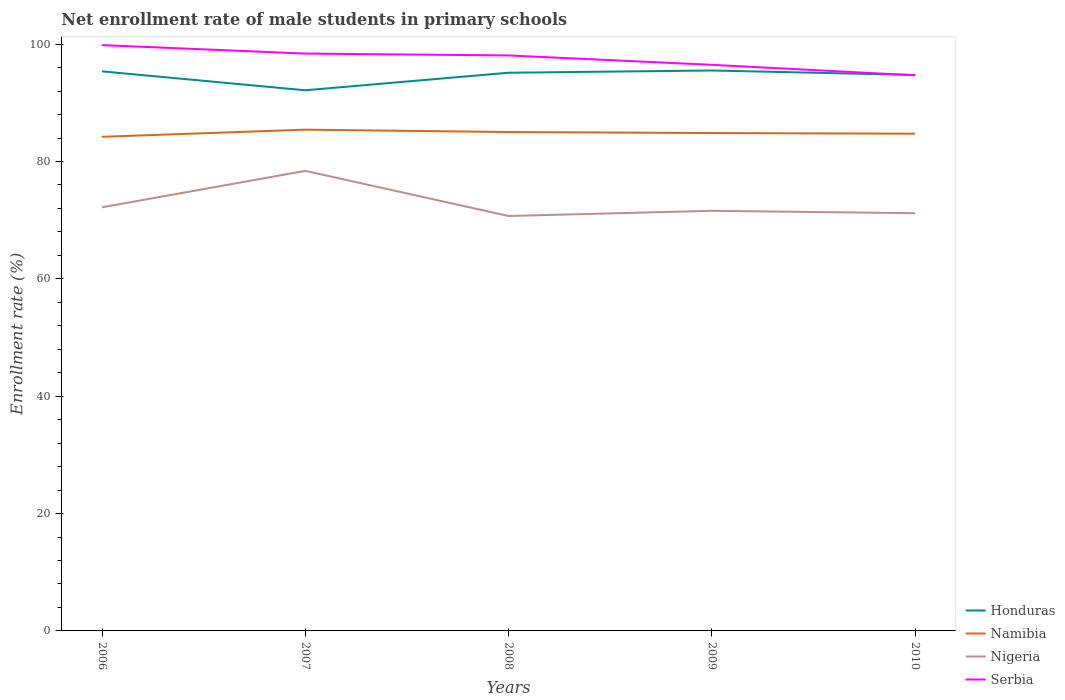Does the line corresponding to Nigeria intersect with the line corresponding to Serbia?
Keep it short and to the point. No. Across all years, what is the maximum net enrollment rate of male students in primary schools in Honduras?
Give a very brief answer. 92.14. What is the total net enrollment rate of male students in primary schools in Honduras in the graph?
Your answer should be compact. -2.99. What is the difference between the highest and the second highest net enrollment rate of male students in primary schools in Serbia?
Give a very brief answer. 5.15. What is the difference between the highest and the lowest net enrollment rate of male students in primary schools in Nigeria?
Keep it short and to the point. 1. How many years are there in the graph?
Your response must be concise. 5. Does the graph contain grids?
Offer a terse response. No. How many legend labels are there?
Your answer should be compact. 4. What is the title of the graph?
Ensure brevity in your answer.  Net enrollment rate of male students in primary schools. What is the label or title of the X-axis?
Provide a succinct answer. Years. What is the label or title of the Y-axis?
Your answer should be very brief. Enrollment rate (%). What is the Enrollment rate (%) of Honduras in 2006?
Keep it short and to the point. 95.37. What is the Enrollment rate (%) in Namibia in 2006?
Provide a short and direct response. 84.21. What is the Enrollment rate (%) of Nigeria in 2006?
Provide a succinct answer. 72.2. What is the Enrollment rate (%) of Serbia in 2006?
Your answer should be compact. 99.84. What is the Enrollment rate (%) of Honduras in 2007?
Your answer should be compact. 92.14. What is the Enrollment rate (%) of Namibia in 2007?
Offer a terse response. 85.43. What is the Enrollment rate (%) of Nigeria in 2007?
Your response must be concise. 78.4. What is the Enrollment rate (%) in Serbia in 2007?
Your answer should be compact. 98.4. What is the Enrollment rate (%) in Honduras in 2008?
Offer a very short reply. 95.13. What is the Enrollment rate (%) in Namibia in 2008?
Provide a succinct answer. 85.02. What is the Enrollment rate (%) in Nigeria in 2008?
Your response must be concise. 70.72. What is the Enrollment rate (%) of Serbia in 2008?
Keep it short and to the point. 98.08. What is the Enrollment rate (%) in Honduras in 2009?
Offer a terse response. 95.51. What is the Enrollment rate (%) in Namibia in 2009?
Give a very brief answer. 84.85. What is the Enrollment rate (%) in Nigeria in 2009?
Ensure brevity in your answer.  71.6. What is the Enrollment rate (%) of Serbia in 2009?
Your answer should be compact. 96.48. What is the Enrollment rate (%) of Honduras in 2010?
Keep it short and to the point. 94.75. What is the Enrollment rate (%) in Namibia in 2010?
Your answer should be very brief. 84.74. What is the Enrollment rate (%) in Nigeria in 2010?
Ensure brevity in your answer.  71.19. What is the Enrollment rate (%) of Serbia in 2010?
Provide a short and direct response. 94.69. Across all years, what is the maximum Enrollment rate (%) of Honduras?
Make the answer very short. 95.51. Across all years, what is the maximum Enrollment rate (%) in Namibia?
Your response must be concise. 85.43. Across all years, what is the maximum Enrollment rate (%) of Nigeria?
Provide a short and direct response. 78.4. Across all years, what is the maximum Enrollment rate (%) of Serbia?
Provide a succinct answer. 99.84. Across all years, what is the minimum Enrollment rate (%) in Honduras?
Offer a terse response. 92.14. Across all years, what is the minimum Enrollment rate (%) in Namibia?
Make the answer very short. 84.21. Across all years, what is the minimum Enrollment rate (%) of Nigeria?
Keep it short and to the point. 70.72. Across all years, what is the minimum Enrollment rate (%) of Serbia?
Provide a short and direct response. 94.69. What is the total Enrollment rate (%) in Honduras in the graph?
Give a very brief answer. 472.9. What is the total Enrollment rate (%) in Namibia in the graph?
Provide a short and direct response. 424.26. What is the total Enrollment rate (%) in Nigeria in the graph?
Keep it short and to the point. 364.11. What is the total Enrollment rate (%) of Serbia in the graph?
Ensure brevity in your answer.  487.48. What is the difference between the Enrollment rate (%) of Honduras in 2006 and that in 2007?
Offer a very short reply. 3.22. What is the difference between the Enrollment rate (%) in Namibia in 2006 and that in 2007?
Ensure brevity in your answer.  -1.22. What is the difference between the Enrollment rate (%) in Nigeria in 2006 and that in 2007?
Keep it short and to the point. -6.21. What is the difference between the Enrollment rate (%) in Serbia in 2006 and that in 2007?
Ensure brevity in your answer.  1.44. What is the difference between the Enrollment rate (%) in Honduras in 2006 and that in 2008?
Offer a very short reply. 0.24. What is the difference between the Enrollment rate (%) of Namibia in 2006 and that in 2008?
Make the answer very short. -0.81. What is the difference between the Enrollment rate (%) of Nigeria in 2006 and that in 2008?
Ensure brevity in your answer.  1.48. What is the difference between the Enrollment rate (%) in Serbia in 2006 and that in 2008?
Ensure brevity in your answer.  1.76. What is the difference between the Enrollment rate (%) in Honduras in 2006 and that in 2009?
Your answer should be very brief. -0.15. What is the difference between the Enrollment rate (%) in Namibia in 2006 and that in 2009?
Your response must be concise. -0.64. What is the difference between the Enrollment rate (%) in Nigeria in 2006 and that in 2009?
Provide a succinct answer. 0.6. What is the difference between the Enrollment rate (%) in Serbia in 2006 and that in 2009?
Give a very brief answer. 3.36. What is the difference between the Enrollment rate (%) of Honduras in 2006 and that in 2010?
Give a very brief answer. 0.61. What is the difference between the Enrollment rate (%) of Namibia in 2006 and that in 2010?
Make the answer very short. -0.53. What is the difference between the Enrollment rate (%) of Nigeria in 2006 and that in 2010?
Keep it short and to the point. 1. What is the difference between the Enrollment rate (%) of Serbia in 2006 and that in 2010?
Your answer should be very brief. 5.15. What is the difference between the Enrollment rate (%) of Honduras in 2007 and that in 2008?
Your response must be concise. -2.99. What is the difference between the Enrollment rate (%) of Namibia in 2007 and that in 2008?
Ensure brevity in your answer.  0.41. What is the difference between the Enrollment rate (%) in Nigeria in 2007 and that in 2008?
Provide a short and direct response. 7.69. What is the difference between the Enrollment rate (%) of Serbia in 2007 and that in 2008?
Make the answer very short. 0.32. What is the difference between the Enrollment rate (%) of Honduras in 2007 and that in 2009?
Your answer should be compact. -3.37. What is the difference between the Enrollment rate (%) of Namibia in 2007 and that in 2009?
Your response must be concise. 0.58. What is the difference between the Enrollment rate (%) in Nigeria in 2007 and that in 2009?
Give a very brief answer. 6.81. What is the difference between the Enrollment rate (%) in Serbia in 2007 and that in 2009?
Your answer should be compact. 1.92. What is the difference between the Enrollment rate (%) in Honduras in 2007 and that in 2010?
Keep it short and to the point. -2.61. What is the difference between the Enrollment rate (%) of Namibia in 2007 and that in 2010?
Ensure brevity in your answer.  0.69. What is the difference between the Enrollment rate (%) of Nigeria in 2007 and that in 2010?
Make the answer very short. 7.21. What is the difference between the Enrollment rate (%) in Serbia in 2007 and that in 2010?
Provide a succinct answer. 3.71. What is the difference between the Enrollment rate (%) in Honduras in 2008 and that in 2009?
Your answer should be very brief. -0.38. What is the difference between the Enrollment rate (%) of Namibia in 2008 and that in 2009?
Keep it short and to the point. 0.17. What is the difference between the Enrollment rate (%) of Nigeria in 2008 and that in 2009?
Provide a short and direct response. -0.88. What is the difference between the Enrollment rate (%) in Serbia in 2008 and that in 2009?
Your answer should be compact. 1.6. What is the difference between the Enrollment rate (%) of Honduras in 2008 and that in 2010?
Your response must be concise. 0.38. What is the difference between the Enrollment rate (%) in Namibia in 2008 and that in 2010?
Provide a short and direct response. 0.28. What is the difference between the Enrollment rate (%) in Nigeria in 2008 and that in 2010?
Your answer should be very brief. -0.48. What is the difference between the Enrollment rate (%) in Serbia in 2008 and that in 2010?
Provide a succinct answer. 3.39. What is the difference between the Enrollment rate (%) in Honduras in 2009 and that in 2010?
Make the answer very short. 0.76. What is the difference between the Enrollment rate (%) in Namibia in 2009 and that in 2010?
Offer a terse response. 0.11. What is the difference between the Enrollment rate (%) in Nigeria in 2009 and that in 2010?
Give a very brief answer. 0.4. What is the difference between the Enrollment rate (%) in Serbia in 2009 and that in 2010?
Your answer should be very brief. 1.79. What is the difference between the Enrollment rate (%) in Honduras in 2006 and the Enrollment rate (%) in Namibia in 2007?
Make the answer very short. 9.93. What is the difference between the Enrollment rate (%) of Honduras in 2006 and the Enrollment rate (%) of Nigeria in 2007?
Offer a very short reply. 16.96. What is the difference between the Enrollment rate (%) in Honduras in 2006 and the Enrollment rate (%) in Serbia in 2007?
Ensure brevity in your answer.  -3.03. What is the difference between the Enrollment rate (%) of Namibia in 2006 and the Enrollment rate (%) of Nigeria in 2007?
Offer a terse response. 5.81. What is the difference between the Enrollment rate (%) of Namibia in 2006 and the Enrollment rate (%) of Serbia in 2007?
Provide a short and direct response. -14.19. What is the difference between the Enrollment rate (%) in Nigeria in 2006 and the Enrollment rate (%) in Serbia in 2007?
Keep it short and to the point. -26.2. What is the difference between the Enrollment rate (%) of Honduras in 2006 and the Enrollment rate (%) of Namibia in 2008?
Your response must be concise. 10.34. What is the difference between the Enrollment rate (%) in Honduras in 2006 and the Enrollment rate (%) in Nigeria in 2008?
Your answer should be very brief. 24.65. What is the difference between the Enrollment rate (%) in Honduras in 2006 and the Enrollment rate (%) in Serbia in 2008?
Provide a succinct answer. -2.71. What is the difference between the Enrollment rate (%) of Namibia in 2006 and the Enrollment rate (%) of Nigeria in 2008?
Provide a short and direct response. 13.5. What is the difference between the Enrollment rate (%) of Namibia in 2006 and the Enrollment rate (%) of Serbia in 2008?
Your response must be concise. -13.86. What is the difference between the Enrollment rate (%) of Nigeria in 2006 and the Enrollment rate (%) of Serbia in 2008?
Make the answer very short. -25.88. What is the difference between the Enrollment rate (%) of Honduras in 2006 and the Enrollment rate (%) of Namibia in 2009?
Give a very brief answer. 10.51. What is the difference between the Enrollment rate (%) in Honduras in 2006 and the Enrollment rate (%) in Nigeria in 2009?
Keep it short and to the point. 23.77. What is the difference between the Enrollment rate (%) of Honduras in 2006 and the Enrollment rate (%) of Serbia in 2009?
Offer a terse response. -1.12. What is the difference between the Enrollment rate (%) of Namibia in 2006 and the Enrollment rate (%) of Nigeria in 2009?
Ensure brevity in your answer.  12.62. What is the difference between the Enrollment rate (%) of Namibia in 2006 and the Enrollment rate (%) of Serbia in 2009?
Provide a short and direct response. -12.27. What is the difference between the Enrollment rate (%) of Nigeria in 2006 and the Enrollment rate (%) of Serbia in 2009?
Your response must be concise. -24.29. What is the difference between the Enrollment rate (%) in Honduras in 2006 and the Enrollment rate (%) in Namibia in 2010?
Keep it short and to the point. 10.62. What is the difference between the Enrollment rate (%) of Honduras in 2006 and the Enrollment rate (%) of Nigeria in 2010?
Provide a succinct answer. 24.17. What is the difference between the Enrollment rate (%) of Honduras in 2006 and the Enrollment rate (%) of Serbia in 2010?
Offer a terse response. 0.68. What is the difference between the Enrollment rate (%) in Namibia in 2006 and the Enrollment rate (%) in Nigeria in 2010?
Make the answer very short. 13.02. What is the difference between the Enrollment rate (%) of Namibia in 2006 and the Enrollment rate (%) of Serbia in 2010?
Offer a very short reply. -10.48. What is the difference between the Enrollment rate (%) in Nigeria in 2006 and the Enrollment rate (%) in Serbia in 2010?
Give a very brief answer. -22.49. What is the difference between the Enrollment rate (%) in Honduras in 2007 and the Enrollment rate (%) in Namibia in 2008?
Keep it short and to the point. 7.12. What is the difference between the Enrollment rate (%) in Honduras in 2007 and the Enrollment rate (%) in Nigeria in 2008?
Give a very brief answer. 21.43. What is the difference between the Enrollment rate (%) in Honduras in 2007 and the Enrollment rate (%) in Serbia in 2008?
Make the answer very short. -5.94. What is the difference between the Enrollment rate (%) in Namibia in 2007 and the Enrollment rate (%) in Nigeria in 2008?
Your response must be concise. 14.71. What is the difference between the Enrollment rate (%) in Namibia in 2007 and the Enrollment rate (%) in Serbia in 2008?
Your response must be concise. -12.65. What is the difference between the Enrollment rate (%) in Nigeria in 2007 and the Enrollment rate (%) in Serbia in 2008?
Make the answer very short. -19.67. What is the difference between the Enrollment rate (%) in Honduras in 2007 and the Enrollment rate (%) in Namibia in 2009?
Give a very brief answer. 7.29. What is the difference between the Enrollment rate (%) of Honduras in 2007 and the Enrollment rate (%) of Nigeria in 2009?
Provide a short and direct response. 20.54. What is the difference between the Enrollment rate (%) in Honduras in 2007 and the Enrollment rate (%) in Serbia in 2009?
Keep it short and to the point. -4.34. What is the difference between the Enrollment rate (%) in Namibia in 2007 and the Enrollment rate (%) in Nigeria in 2009?
Ensure brevity in your answer.  13.83. What is the difference between the Enrollment rate (%) of Namibia in 2007 and the Enrollment rate (%) of Serbia in 2009?
Provide a succinct answer. -11.05. What is the difference between the Enrollment rate (%) of Nigeria in 2007 and the Enrollment rate (%) of Serbia in 2009?
Make the answer very short. -18.08. What is the difference between the Enrollment rate (%) of Honduras in 2007 and the Enrollment rate (%) of Namibia in 2010?
Offer a very short reply. 7.4. What is the difference between the Enrollment rate (%) of Honduras in 2007 and the Enrollment rate (%) of Nigeria in 2010?
Your response must be concise. 20.95. What is the difference between the Enrollment rate (%) in Honduras in 2007 and the Enrollment rate (%) in Serbia in 2010?
Offer a very short reply. -2.55. What is the difference between the Enrollment rate (%) in Namibia in 2007 and the Enrollment rate (%) in Nigeria in 2010?
Provide a short and direct response. 14.24. What is the difference between the Enrollment rate (%) in Namibia in 2007 and the Enrollment rate (%) in Serbia in 2010?
Ensure brevity in your answer.  -9.26. What is the difference between the Enrollment rate (%) of Nigeria in 2007 and the Enrollment rate (%) of Serbia in 2010?
Offer a terse response. -16.28. What is the difference between the Enrollment rate (%) of Honduras in 2008 and the Enrollment rate (%) of Namibia in 2009?
Give a very brief answer. 10.28. What is the difference between the Enrollment rate (%) of Honduras in 2008 and the Enrollment rate (%) of Nigeria in 2009?
Your response must be concise. 23.53. What is the difference between the Enrollment rate (%) in Honduras in 2008 and the Enrollment rate (%) in Serbia in 2009?
Offer a terse response. -1.35. What is the difference between the Enrollment rate (%) of Namibia in 2008 and the Enrollment rate (%) of Nigeria in 2009?
Your answer should be compact. 13.43. What is the difference between the Enrollment rate (%) in Namibia in 2008 and the Enrollment rate (%) in Serbia in 2009?
Make the answer very short. -11.46. What is the difference between the Enrollment rate (%) of Nigeria in 2008 and the Enrollment rate (%) of Serbia in 2009?
Offer a terse response. -25.77. What is the difference between the Enrollment rate (%) in Honduras in 2008 and the Enrollment rate (%) in Namibia in 2010?
Make the answer very short. 10.39. What is the difference between the Enrollment rate (%) in Honduras in 2008 and the Enrollment rate (%) in Nigeria in 2010?
Offer a terse response. 23.94. What is the difference between the Enrollment rate (%) of Honduras in 2008 and the Enrollment rate (%) of Serbia in 2010?
Offer a terse response. 0.44. What is the difference between the Enrollment rate (%) of Namibia in 2008 and the Enrollment rate (%) of Nigeria in 2010?
Offer a very short reply. 13.83. What is the difference between the Enrollment rate (%) of Namibia in 2008 and the Enrollment rate (%) of Serbia in 2010?
Give a very brief answer. -9.67. What is the difference between the Enrollment rate (%) in Nigeria in 2008 and the Enrollment rate (%) in Serbia in 2010?
Your response must be concise. -23.97. What is the difference between the Enrollment rate (%) of Honduras in 2009 and the Enrollment rate (%) of Namibia in 2010?
Keep it short and to the point. 10.77. What is the difference between the Enrollment rate (%) in Honduras in 2009 and the Enrollment rate (%) in Nigeria in 2010?
Offer a terse response. 24.32. What is the difference between the Enrollment rate (%) of Honduras in 2009 and the Enrollment rate (%) of Serbia in 2010?
Your response must be concise. 0.82. What is the difference between the Enrollment rate (%) in Namibia in 2009 and the Enrollment rate (%) in Nigeria in 2010?
Ensure brevity in your answer.  13.66. What is the difference between the Enrollment rate (%) of Namibia in 2009 and the Enrollment rate (%) of Serbia in 2010?
Ensure brevity in your answer.  -9.84. What is the difference between the Enrollment rate (%) of Nigeria in 2009 and the Enrollment rate (%) of Serbia in 2010?
Offer a very short reply. -23.09. What is the average Enrollment rate (%) in Honduras per year?
Your answer should be compact. 94.58. What is the average Enrollment rate (%) in Namibia per year?
Your response must be concise. 84.85. What is the average Enrollment rate (%) of Nigeria per year?
Provide a short and direct response. 72.82. What is the average Enrollment rate (%) in Serbia per year?
Provide a succinct answer. 97.5. In the year 2006, what is the difference between the Enrollment rate (%) in Honduras and Enrollment rate (%) in Namibia?
Your answer should be compact. 11.15. In the year 2006, what is the difference between the Enrollment rate (%) in Honduras and Enrollment rate (%) in Nigeria?
Offer a terse response. 23.17. In the year 2006, what is the difference between the Enrollment rate (%) of Honduras and Enrollment rate (%) of Serbia?
Make the answer very short. -4.47. In the year 2006, what is the difference between the Enrollment rate (%) of Namibia and Enrollment rate (%) of Nigeria?
Your answer should be compact. 12.02. In the year 2006, what is the difference between the Enrollment rate (%) of Namibia and Enrollment rate (%) of Serbia?
Offer a very short reply. -15.62. In the year 2006, what is the difference between the Enrollment rate (%) in Nigeria and Enrollment rate (%) in Serbia?
Offer a very short reply. -27.64. In the year 2007, what is the difference between the Enrollment rate (%) in Honduras and Enrollment rate (%) in Namibia?
Ensure brevity in your answer.  6.71. In the year 2007, what is the difference between the Enrollment rate (%) in Honduras and Enrollment rate (%) in Nigeria?
Your answer should be very brief. 13.74. In the year 2007, what is the difference between the Enrollment rate (%) in Honduras and Enrollment rate (%) in Serbia?
Ensure brevity in your answer.  -6.26. In the year 2007, what is the difference between the Enrollment rate (%) of Namibia and Enrollment rate (%) of Nigeria?
Provide a succinct answer. 7.03. In the year 2007, what is the difference between the Enrollment rate (%) of Namibia and Enrollment rate (%) of Serbia?
Your answer should be very brief. -12.97. In the year 2007, what is the difference between the Enrollment rate (%) in Nigeria and Enrollment rate (%) in Serbia?
Give a very brief answer. -19.99. In the year 2008, what is the difference between the Enrollment rate (%) in Honduras and Enrollment rate (%) in Namibia?
Offer a very short reply. 10.11. In the year 2008, what is the difference between the Enrollment rate (%) of Honduras and Enrollment rate (%) of Nigeria?
Offer a terse response. 24.41. In the year 2008, what is the difference between the Enrollment rate (%) in Honduras and Enrollment rate (%) in Serbia?
Your response must be concise. -2.95. In the year 2008, what is the difference between the Enrollment rate (%) in Namibia and Enrollment rate (%) in Nigeria?
Ensure brevity in your answer.  14.31. In the year 2008, what is the difference between the Enrollment rate (%) of Namibia and Enrollment rate (%) of Serbia?
Ensure brevity in your answer.  -13.05. In the year 2008, what is the difference between the Enrollment rate (%) in Nigeria and Enrollment rate (%) in Serbia?
Ensure brevity in your answer.  -27.36. In the year 2009, what is the difference between the Enrollment rate (%) in Honduras and Enrollment rate (%) in Namibia?
Ensure brevity in your answer.  10.66. In the year 2009, what is the difference between the Enrollment rate (%) in Honduras and Enrollment rate (%) in Nigeria?
Ensure brevity in your answer.  23.92. In the year 2009, what is the difference between the Enrollment rate (%) of Honduras and Enrollment rate (%) of Serbia?
Provide a short and direct response. -0.97. In the year 2009, what is the difference between the Enrollment rate (%) of Namibia and Enrollment rate (%) of Nigeria?
Your answer should be compact. 13.26. In the year 2009, what is the difference between the Enrollment rate (%) in Namibia and Enrollment rate (%) in Serbia?
Ensure brevity in your answer.  -11.63. In the year 2009, what is the difference between the Enrollment rate (%) of Nigeria and Enrollment rate (%) of Serbia?
Offer a very short reply. -24.88. In the year 2010, what is the difference between the Enrollment rate (%) in Honduras and Enrollment rate (%) in Namibia?
Your answer should be compact. 10.01. In the year 2010, what is the difference between the Enrollment rate (%) in Honduras and Enrollment rate (%) in Nigeria?
Provide a short and direct response. 23.56. In the year 2010, what is the difference between the Enrollment rate (%) of Honduras and Enrollment rate (%) of Serbia?
Keep it short and to the point. 0.06. In the year 2010, what is the difference between the Enrollment rate (%) in Namibia and Enrollment rate (%) in Nigeria?
Provide a succinct answer. 13.55. In the year 2010, what is the difference between the Enrollment rate (%) of Namibia and Enrollment rate (%) of Serbia?
Offer a terse response. -9.95. In the year 2010, what is the difference between the Enrollment rate (%) in Nigeria and Enrollment rate (%) in Serbia?
Your response must be concise. -23.5. What is the ratio of the Enrollment rate (%) of Honduras in 2006 to that in 2007?
Ensure brevity in your answer.  1.03. What is the ratio of the Enrollment rate (%) in Namibia in 2006 to that in 2007?
Make the answer very short. 0.99. What is the ratio of the Enrollment rate (%) in Nigeria in 2006 to that in 2007?
Make the answer very short. 0.92. What is the ratio of the Enrollment rate (%) in Serbia in 2006 to that in 2007?
Offer a very short reply. 1.01. What is the ratio of the Enrollment rate (%) of Namibia in 2006 to that in 2008?
Provide a short and direct response. 0.99. What is the ratio of the Enrollment rate (%) in Nigeria in 2006 to that in 2008?
Offer a very short reply. 1.02. What is the ratio of the Enrollment rate (%) of Serbia in 2006 to that in 2008?
Ensure brevity in your answer.  1.02. What is the ratio of the Enrollment rate (%) in Nigeria in 2006 to that in 2009?
Your answer should be very brief. 1.01. What is the ratio of the Enrollment rate (%) in Serbia in 2006 to that in 2009?
Offer a terse response. 1.03. What is the ratio of the Enrollment rate (%) of Honduras in 2006 to that in 2010?
Your response must be concise. 1.01. What is the ratio of the Enrollment rate (%) in Namibia in 2006 to that in 2010?
Make the answer very short. 0.99. What is the ratio of the Enrollment rate (%) of Nigeria in 2006 to that in 2010?
Keep it short and to the point. 1.01. What is the ratio of the Enrollment rate (%) of Serbia in 2006 to that in 2010?
Give a very brief answer. 1.05. What is the ratio of the Enrollment rate (%) in Honduras in 2007 to that in 2008?
Your answer should be very brief. 0.97. What is the ratio of the Enrollment rate (%) in Nigeria in 2007 to that in 2008?
Offer a terse response. 1.11. What is the ratio of the Enrollment rate (%) in Serbia in 2007 to that in 2008?
Provide a succinct answer. 1. What is the ratio of the Enrollment rate (%) of Honduras in 2007 to that in 2009?
Offer a terse response. 0.96. What is the ratio of the Enrollment rate (%) of Namibia in 2007 to that in 2009?
Keep it short and to the point. 1.01. What is the ratio of the Enrollment rate (%) of Nigeria in 2007 to that in 2009?
Your answer should be very brief. 1.1. What is the ratio of the Enrollment rate (%) of Serbia in 2007 to that in 2009?
Offer a terse response. 1.02. What is the ratio of the Enrollment rate (%) of Honduras in 2007 to that in 2010?
Your response must be concise. 0.97. What is the ratio of the Enrollment rate (%) of Namibia in 2007 to that in 2010?
Keep it short and to the point. 1.01. What is the ratio of the Enrollment rate (%) of Nigeria in 2007 to that in 2010?
Provide a succinct answer. 1.1. What is the ratio of the Enrollment rate (%) in Serbia in 2007 to that in 2010?
Your response must be concise. 1.04. What is the ratio of the Enrollment rate (%) of Serbia in 2008 to that in 2009?
Provide a short and direct response. 1.02. What is the ratio of the Enrollment rate (%) of Honduras in 2008 to that in 2010?
Ensure brevity in your answer.  1. What is the ratio of the Enrollment rate (%) in Namibia in 2008 to that in 2010?
Your answer should be very brief. 1. What is the ratio of the Enrollment rate (%) of Nigeria in 2008 to that in 2010?
Give a very brief answer. 0.99. What is the ratio of the Enrollment rate (%) of Serbia in 2008 to that in 2010?
Ensure brevity in your answer.  1.04. What is the ratio of the Enrollment rate (%) of Honduras in 2009 to that in 2010?
Your response must be concise. 1.01. What is the ratio of the Enrollment rate (%) of Namibia in 2009 to that in 2010?
Your answer should be very brief. 1. What is the ratio of the Enrollment rate (%) in Serbia in 2009 to that in 2010?
Your answer should be compact. 1.02. What is the difference between the highest and the second highest Enrollment rate (%) in Honduras?
Your answer should be compact. 0.15. What is the difference between the highest and the second highest Enrollment rate (%) in Namibia?
Provide a succinct answer. 0.41. What is the difference between the highest and the second highest Enrollment rate (%) in Nigeria?
Your response must be concise. 6.21. What is the difference between the highest and the second highest Enrollment rate (%) of Serbia?
Offer a terse response. 1.44. What is the difference between the highest and the lowest Enrollment rate (%) of Honduras?
Make the answer very short. 3.37. What is the difference between the highest and the lowest Enrollment rate (%) of Namibia?
Your answer should be very brief. 1.22. What is the difference between the highest and the lowest Enrollment rate (%) in Nigeria?
Offer a terse response. 7.69. What is the difference between the highest and the lowest Enrollment rate (%) of Serbia?
Ensure brevity in your answer.  5.15. 